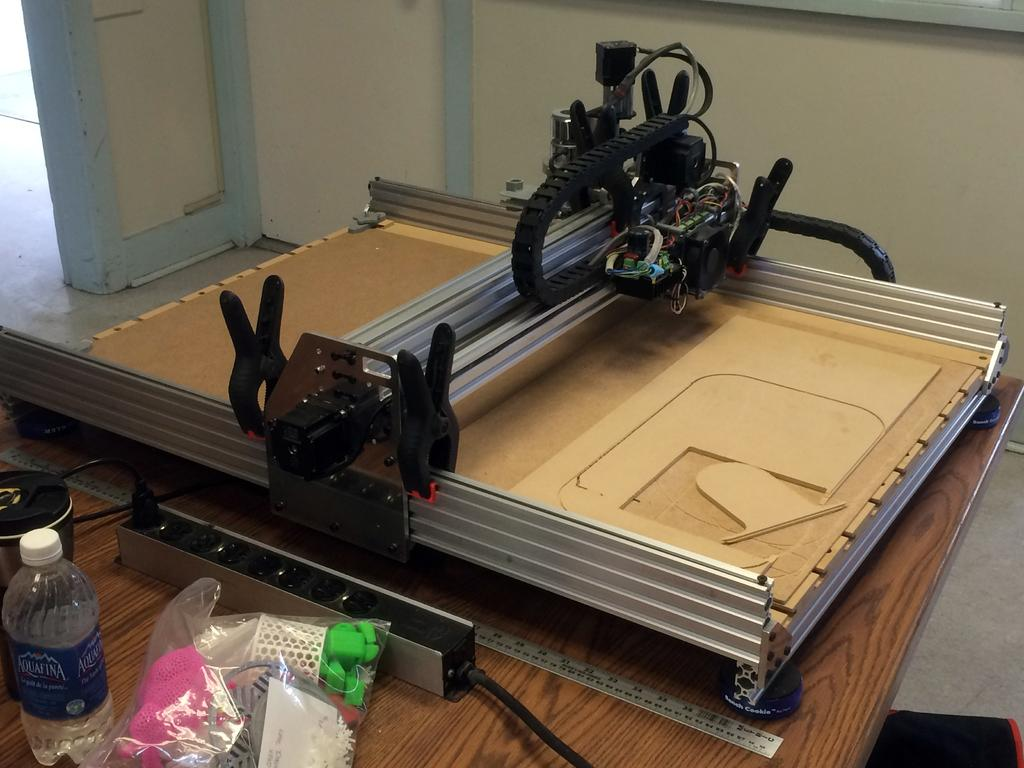What object is located on the table in the image? There is a machine on the table. What can be found beside the machine on the table? There is a scale beside the machine. What type of container is visible on or near the table? There is a bottle on or near the table. What else is present on or near the table in the image? There is a packet with some things on or near the table. How does the machine control the poison in the image? There is no mention of poison in the image, and the machine's purpose is not specified. 